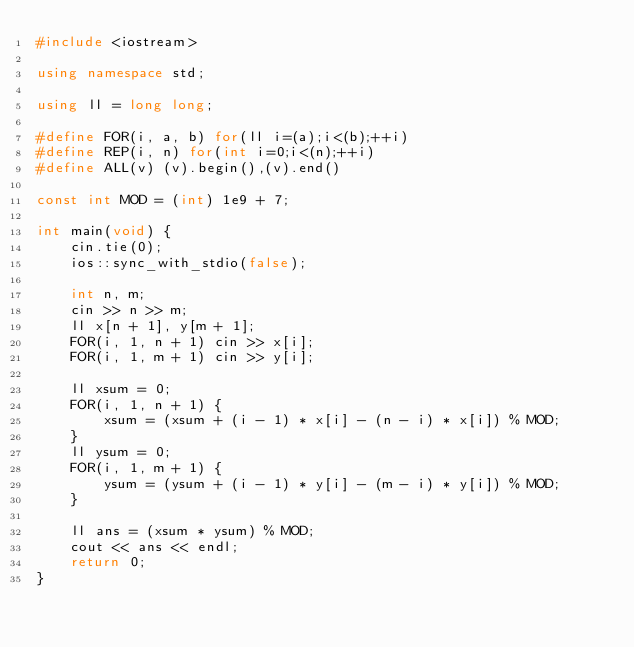<code> <loc_0><loc_0><loc_500><loc_500><_C++_>#include <iostream>

using namespace std;

using ll = long long;

#define FOR(i, a, b) for(ll i=(a);i<(b);++i)
#define REP(i, n) for(int i=0;i<(n);++i)
#define ALL(v) (v).begin(),(v).end()

const int MOD = (int) 1e9 + 7;

int main(void) {
    cin.tie(0);
    ios::sync_with_stdio(false);

    int n, m;
    cin >> n >> m;
    ll x[n + 1], y[m + 1];
    FOR(i, 1, n + 1) cin >> x[i];
    FOR(i, 1, m + 1) cin >> y[i];

    ll xsum = 0;
    FOR(i, 1, n + 1) {
        xsum = (xsum + (i - 1) * x[i] - (n - i) * x[i]) % MOD;
    }
    ll ysum = 0;
    FOR(i, 1, m + 1) {
        ysum = (ysum + (i - 1) * y[i] - (m - i) * y[i]) % MOD;
    }

    ll ans = (xsum * ysum) % MOD;
    cout << ans << endl;
    return 0;
}</code> 